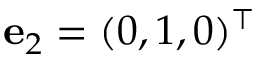<formula> <loc_0><loc_0><loc_500><loc_500>{ \mathbf e } _ { 2 } = ( 0 , 1 , 0 ) ^ { \top }</formula> 